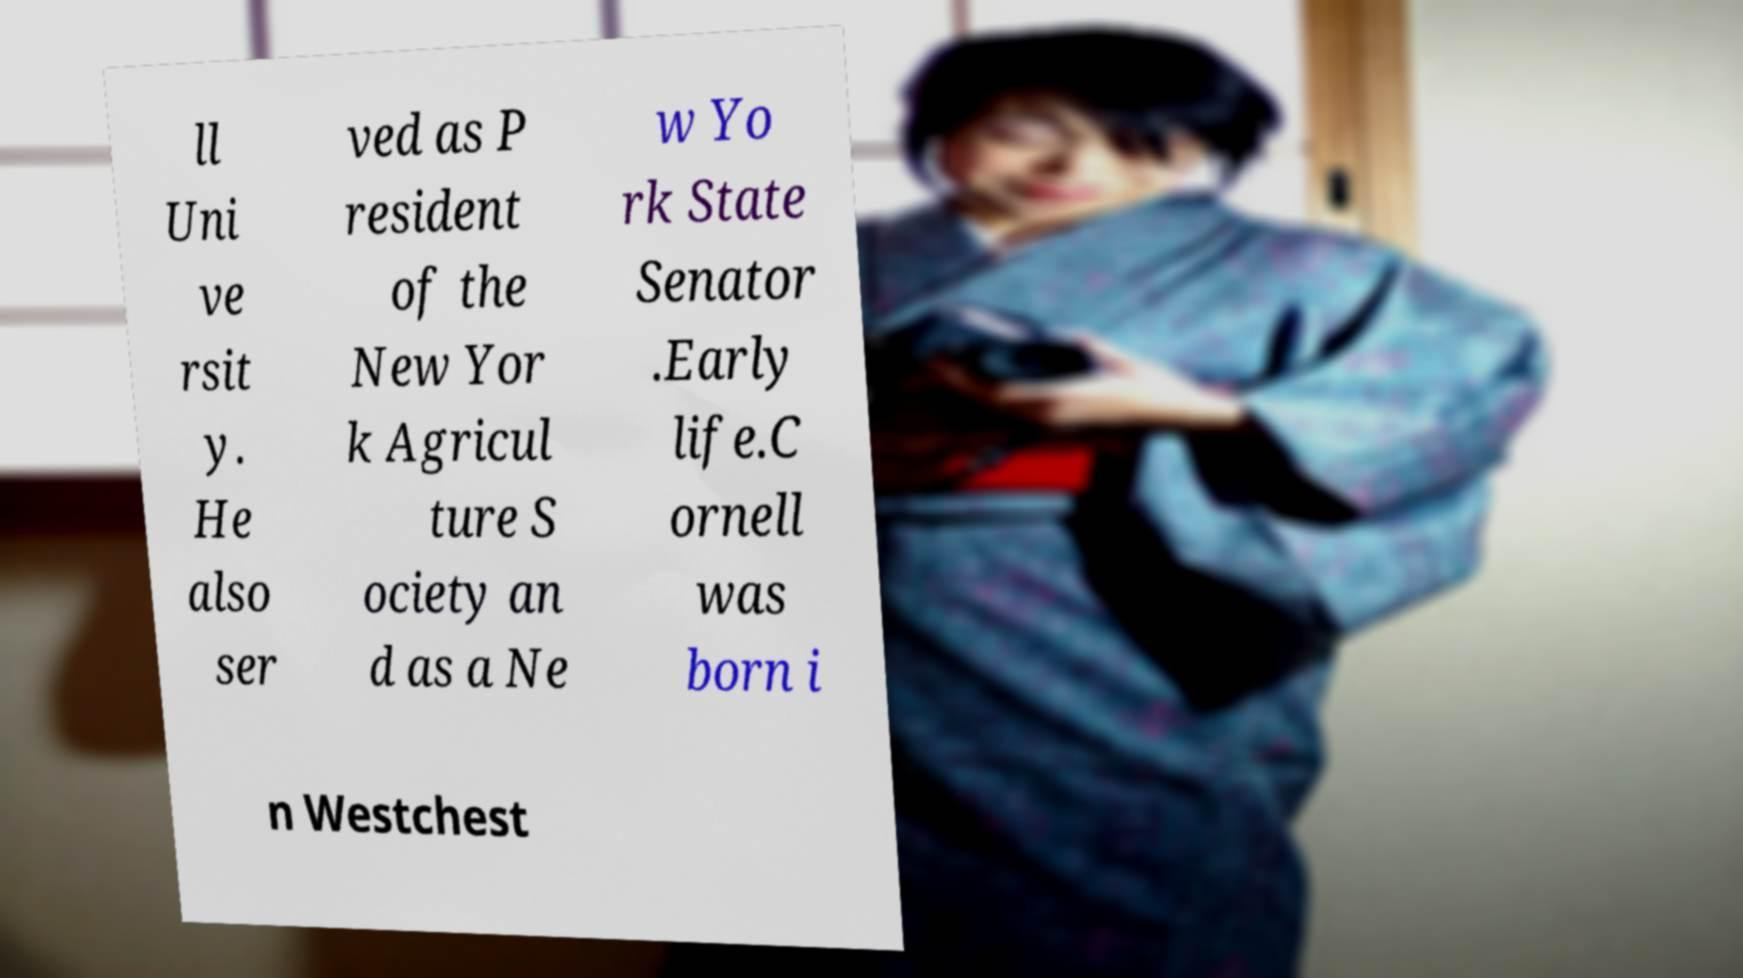Could you extract and type out the text from this image? ll Uni ve rsit y. He also ser ved as P resident of the New Yor k Agricul ture S ociety an d as a Ne w Yo rk State Senator .Early life.C ornell was born i n Westchest 